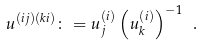<formula> <loc_0><loc_0><loc_500><loc_500>u ^ { ( i j ) ( k i ) } \colon = u ^ { ( i ) } _ { j } \left ( u ^ { ( i ) } _ { k } \right ) ^ { - 1 } \ .</formula> 